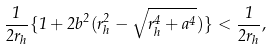<formula> <loc_0><loc_0><loc_500><loc_500>\frac { 1 } { 2 r _ { h } } \{ 1 + 2 b ^ { 2 } ( r _ { h } ^ { 2 } - \sqrt { r _ { h } ^ { 4 } + a ^ { 4 } } ) \} < \frac { 1 } { 2 r _ { h } } ,</formula> 